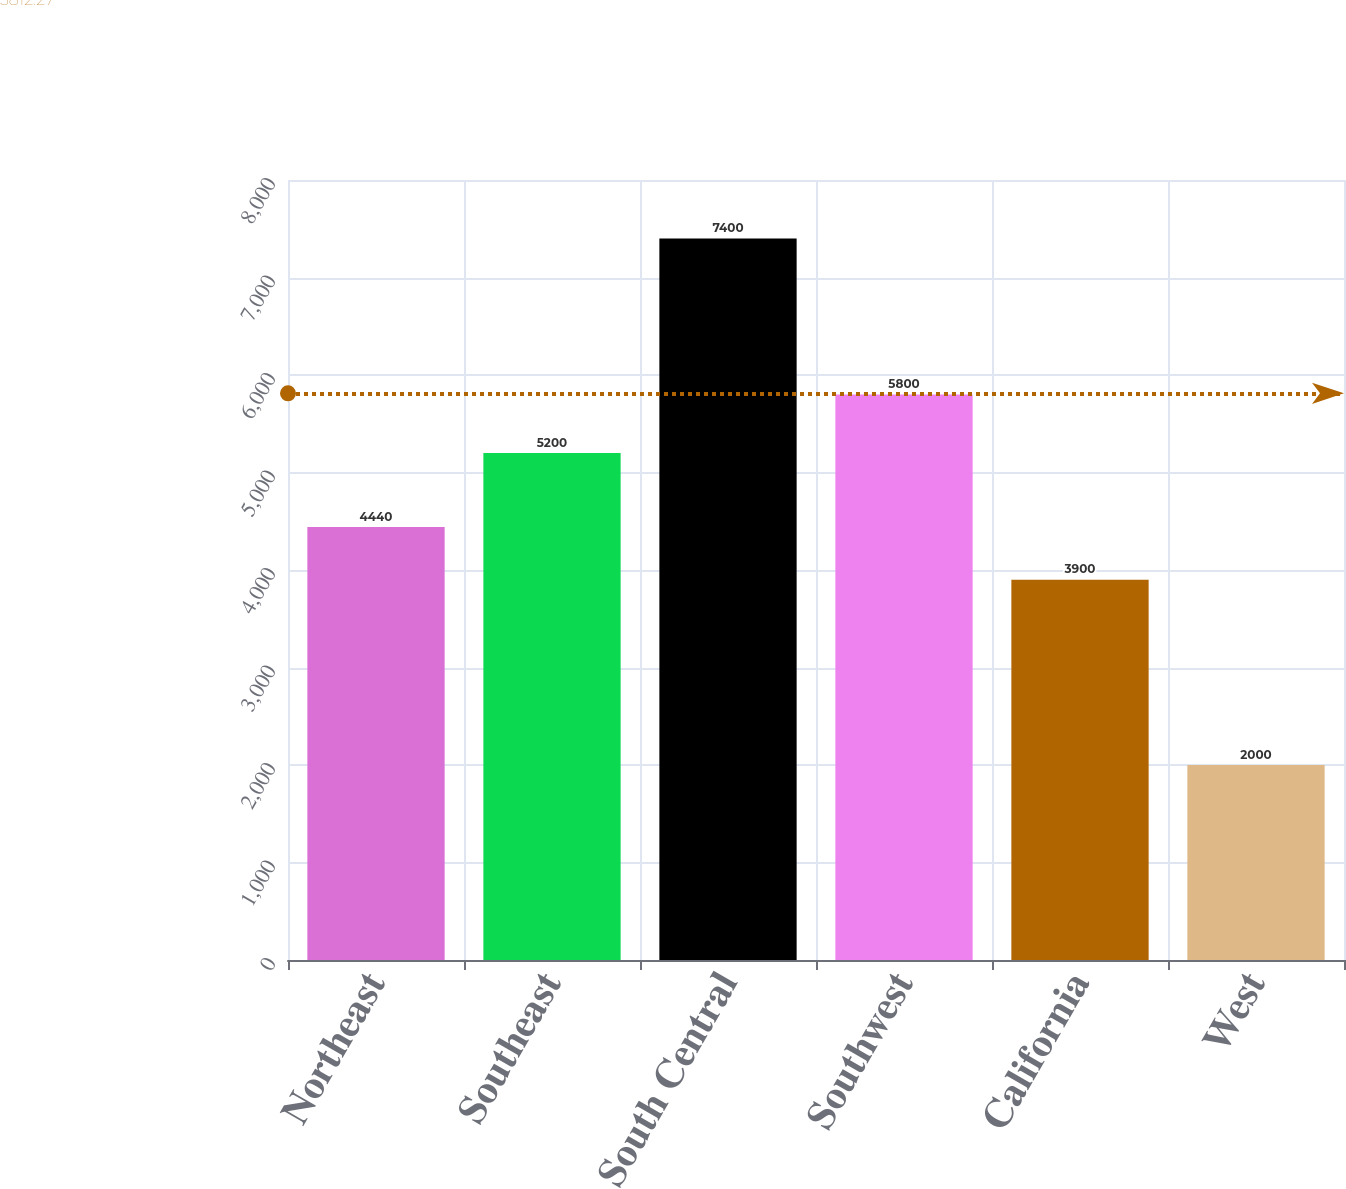Convert chart to OTSL. <chart><loc_0><loc_0><loc_500><loc_500><bar_chart><fcel>Northeast<fcel>Southeast<fcel>South Central<fcel>Southwest<fcel>California<fcel>West<nl><fcel>4440<fcel>5200<fcel>7400<fcel>5800<fcel>3900<fcel>2000<nl></chart> 